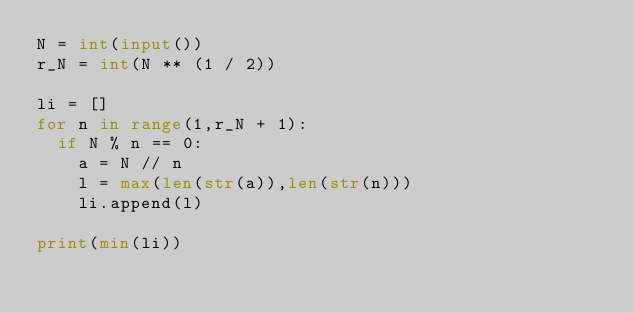<code> <loc_0><loc_0><loc_500><loc_500><_Python_>N = int(input())
r_N = int(N ** (1 / 2))
 
li = []
for n in range(1,r_N + 1):
  if N % n == 0:
    a = N // n
    l = max(len(str(a)),len(str(n)))
  	li.append(l)
    
print(min(li))</code> 